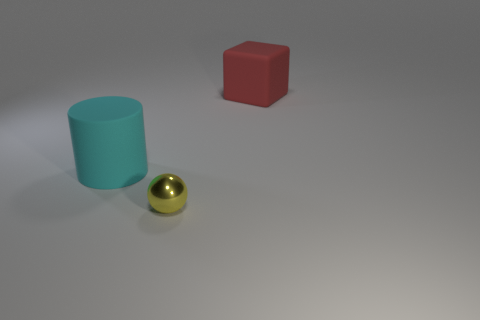Add 2 tiny green things. How many objects exist? 5 Subtract all balls. How many objects are left? 2 Add 3 large rubber cubes. How many large rubber cubes exist? 4 Subtract 0 gray spheres. How many objects are left? 3 Subtract all small yellow objects. Subtract all gray cubes. How many objects are left? 2 Add 2 cyan things. How many cyan things are left? 3 